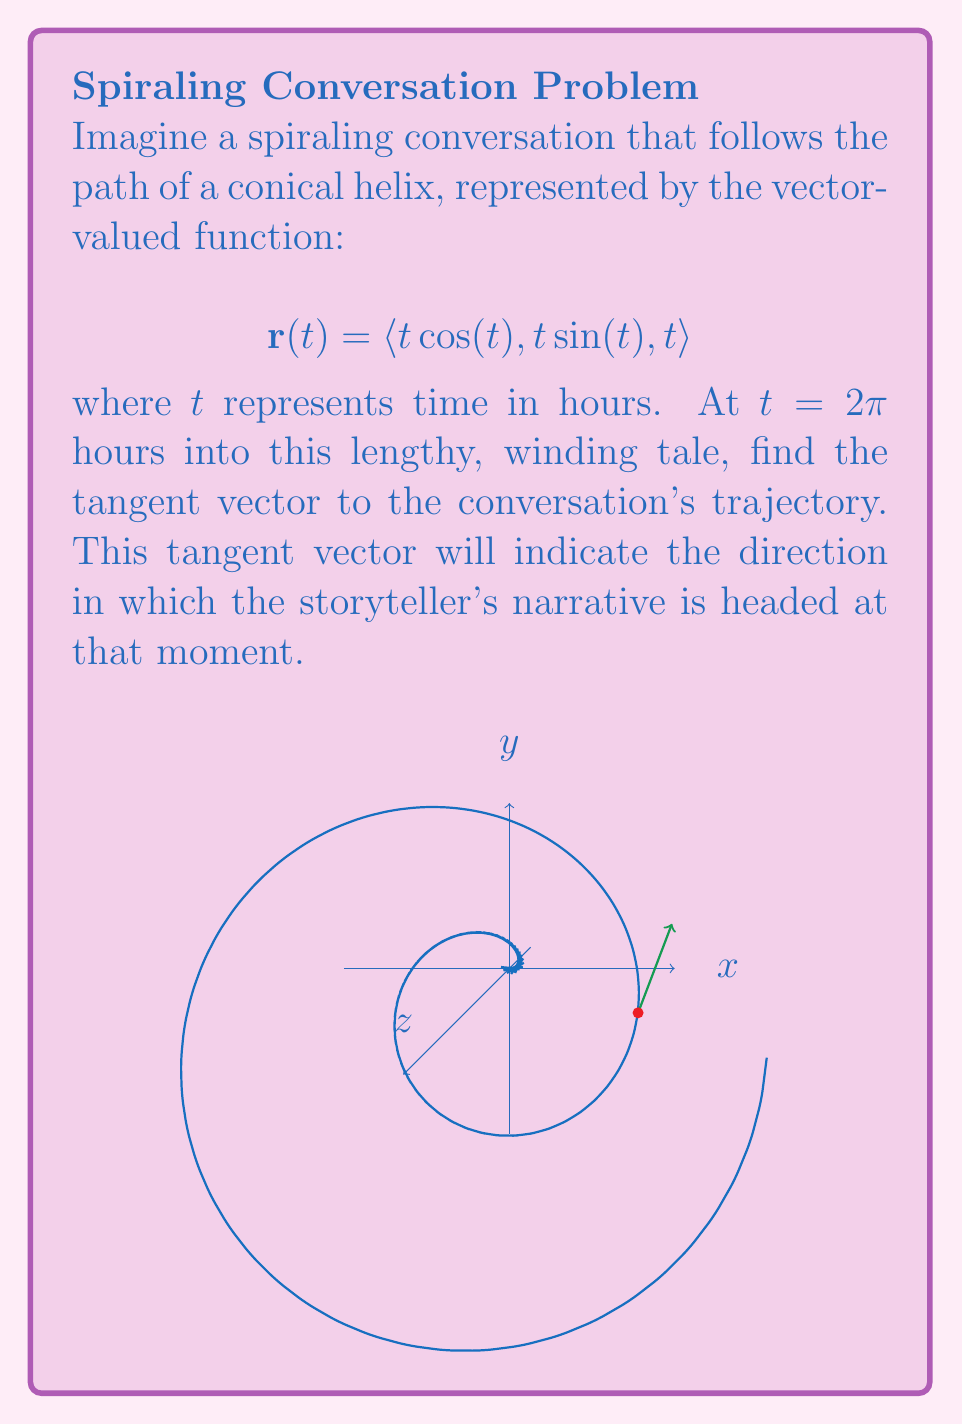Show me your answer to this math problem. To find the tangent vector at $t = 2\pi$, we need to calculate the derivative of the position vector $\mathbf{r}(t)$ and then evaluate it at $t = 2\pi$. Let's break this down step-by-step:

1) The tangent vector is given by $\mathbf{r}'(t)$. We need to differentiate each component of $\mathbf{r}(t)$:

   $$\mathbf{r}'(t) = \langle \frac{d}{dt}(t\cos(t)), \frac{d}{dt}(t\sin(t)), \frac{d}{dt}(t) \rangle$$

2) Using the product rule and chain rule:

   $$\mathbf{r}'(t) = \langle \cos(t) - t\sin(t), \sin(t) + t\cos(t), 1 \rangle$$

3) Now, we evaluate this at $t = 2\pi$:

   $$\mathbf{r}'(2\pi) = \langle \cos(2\pi) - 2\pi\sin(2\pi), \sin(2\pi) + 2\pi\cos(2\pi), 1 \rangle$$

4) Simplify, knowing that $\cos(2\pi) = 1$ and $\sin(2\pi) = 0$:

   $$\mathbf{r}'(2\pi) = \langle 1 - 0, 0 + 2\pi(1), 1 \rangle = \langle 1, 2\pi, 1 \rangle$$

This vector $\langle 1, 2\pi, 1 \rangle$ represents the direction in which the conversation is headed at $t = 2\pi$ hours into the story.
Answer: $\langle 1, 2\pi, 1 \rangle$ 